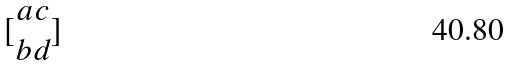Convert formula to latex. <formula><loc_0><loc_0><loc_500><loc_500>[ \begin{matrix} a c \\ b d \end{matrix} ]</formula> 